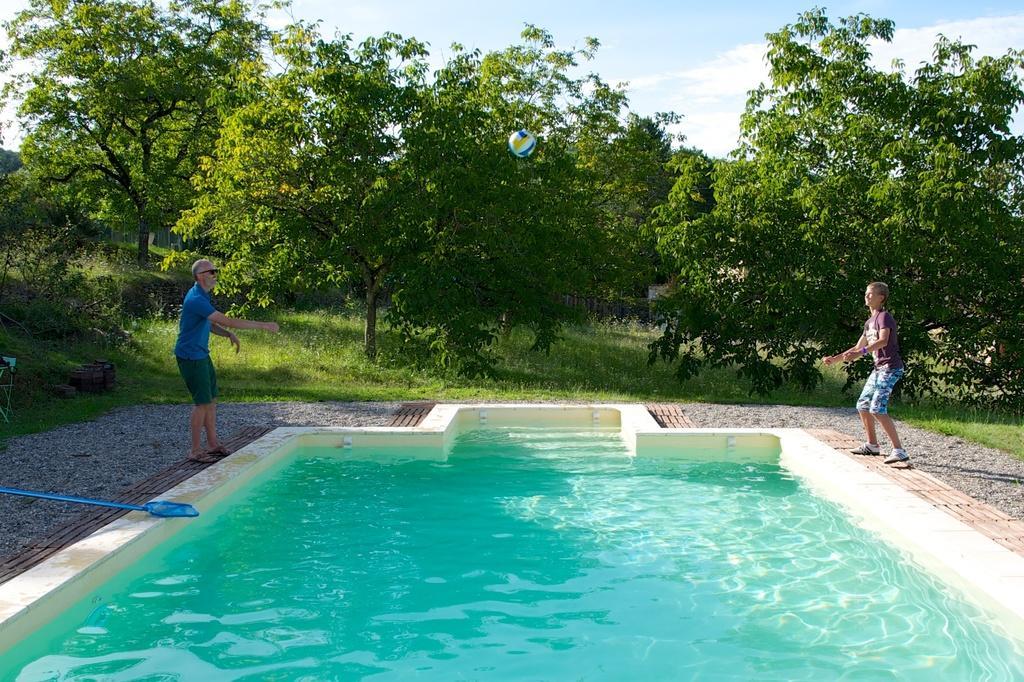How would you summarize this image in a sentence or two? This picture is clicked to outside. In the center we can see a water body and a ball which is in the air and we can see the persons standing on the ground and we can see the gravels, green grass, plants, trees, sky and some other objects. 